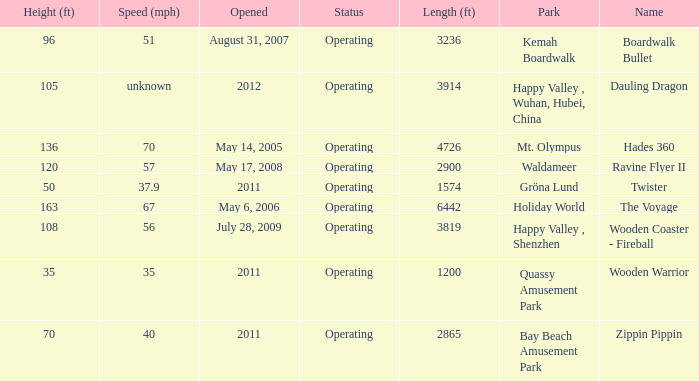What is the extent of the coaster with the undetermined pace? 3914.0. 